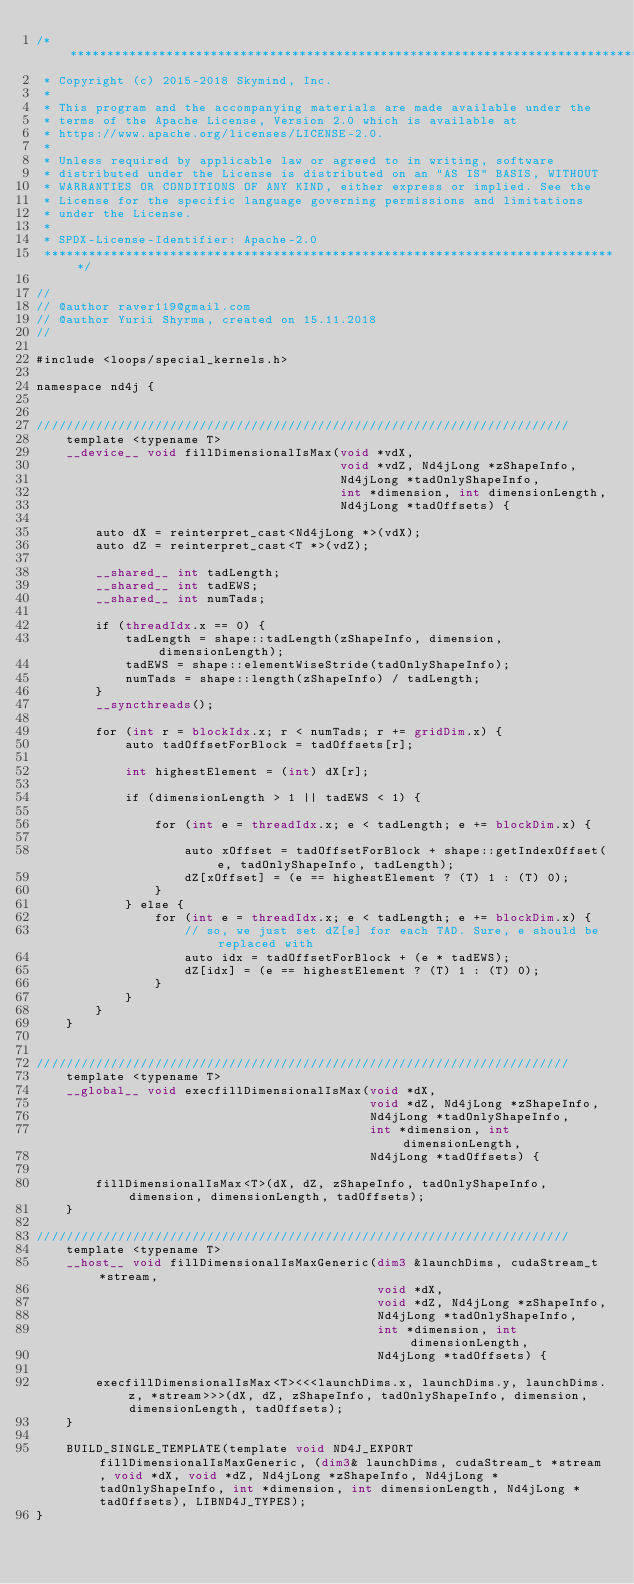<code> <loc_0><loc_0><loc_500><loc_500><_Cuda_>/*******************************************************************************
 * Copyright (c) 2015-2018 Skymind, Inc.
 *
 * This program and the accompanying materials are made available under the
 * terms of the Apache License, Version 2.0 which is available at
 * https://www.apache.org/licenses/LICENSE-2.0.
 *
 * Unless required by applicable law or agreed to in writing, software
 * distributed under the License is distributed on an "AS IS" BASIS, WITHOUT
 * WARRANTIES OR CONDITIONS OF ANY KIND, either express or implied. See the
 * License for the specific language governing permissions and limitations
 * under the License.
 *
 * SPDX-License-Identifier: Apache-2.0
 ******************************************************************************/

//
// @author raver119@gmail.com
// @author Yurii Shyrma, created on 15.11.2018
//

#include <loops/special_kernels.h>

namespace nd4j {


////////////////////////////////////////////////////////////////////////
    template <typename T>
    __device__ void fillDimensionalIsMax(void *vdX,
                                         void *vdZ, Nd4jLong *zShapeInfo,
                                         Nd4jLong *tadOnlyShapeInfo,
                                         int *dimension, int dimensionLength,
                                         Nd4jLong *tadOffsets) {

        auto dX = reinterpret_cast<Nd4jLong *>(vdX);
        auto dZ = reinterpret_cast<T *>(vdZ);

        __shared__ int tadLength;
        __shared__ int tadEWS;
        __shared__ int numTads;

        if (threadIdx.x == 0) {
            tadLength = shape::tadLength(zShapeInfo, dimension, dimensionLength);
            tadEWS = shape::elementWiseStride(tadOnlyShapeInfo);
            numTads = shape::length(zShapeInfo) / tadLength;
        }
        __syncthreads();

        for (int r = blockIdx.x; r < numTads; r += gridDim.x) {
            auto tadOffsetForBlock = tadOffsets[r];

            int highestElement = (int) dX[r];

            if (dimensionLength > 1 || tadEWS < 1) {

                for (int e = threadIdx.x; e < tadLength; e += blockDim.x) {

                    auto xOffset = tadOffsetForBlock + shape::getIndexOffset(e, tadOnlyShapeInfo, tadLength);
                    dZ[xOffset] = (e == highestElement ? (T) 1 : (T) 0);
                }
            } else {
                for (int e = threadIdx.x; e < tadLength; e += blockDim.x) {
                    // so, we just set dZ[e] for each TAD. Sure, e should be replaced with
                    auto idx = tadOffsetForBlock + (e * tadEWS);
                    dZ[idx] = (e == highestElement ? (T) 1 : (T) 0);
                }
            }
        }
    }


////////////////////////////////////////////////////////////////////////
    template <typename T>
    __global__ void execfillDimensionalIsMax(void *dX,
                                             void *dZ, Nd4jLong *zShapeInfo,
                                             Nd4jLong *tadOnlyShapeInfo,
                                             int *dimension, int dimensionLength,
                                             Nd4jLong *tadOffsets) {

        fillDimensionalIsMax<T>(dX, dZ, zShapeInfo, tadOnlyShapeInfo, dimension, dimensionLength, tadOffsets);
    }

////////////////////////////////////////////////////////////////////////
    template <typename T>
    __host__ void fillDimensionalIsMaxGeneric(dim3 &launchDims, cudaStream_t *stream,
                                              void *dX,
                                              void *dZ, Nd4jLong *zShapeInfo,
                                              Nd4jLong *tadOnlyShapeInfo,
                                              int *dimension, int dimensionLength,
                                              Nd4jLong *tadOffsets) {

        execfillDimensionalIsMax<T><<<launchDims.x, launchDims.y, launchDims.z, *stream>>>(dX, dZ, zShapeInfo, tadOnlyShapeInfo, dimension, dimensionLength, tadOffsets);
    }

    BUILD_SINGLE_TEMPLATE(template void ND4J_EXPORT fillDimensionalIsMaxGeneric, (dim3& launchDims, cudaStream_t *stream, void *dX, void *dZ, Nd4jLong *zShapeInfo, Nd4jLong *tadOnlyShapeInfo, int *dimension, int dimensionLength, Nd4jLong *tadOffsets), LIBND4J_TYPES);
}</code> 